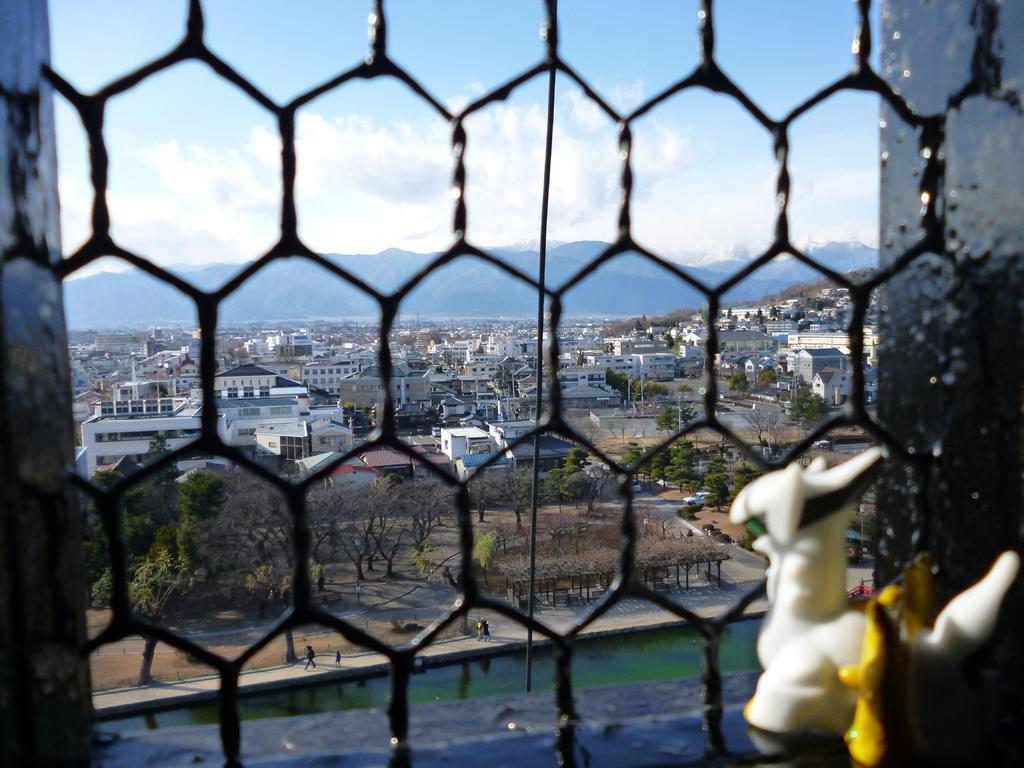Please provide a concise description of this image. In this image we can see a window. From the window we can see water, person's, trees, plants, road, vehicles, poles, buildings, hills, sky and clouds. 